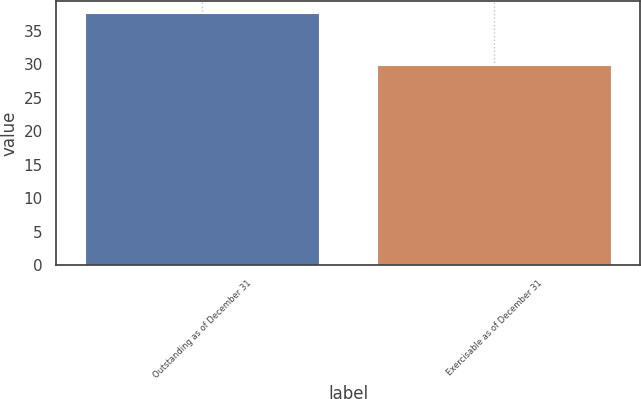<chart> <loc_0><loc_0><loc_500><loc_500><bar_chart><fcel>Outstanding as of December 31<fcel>Exercisable as of December 31<nl><fcel>37.63<fcel>29.82<nl></chart> 